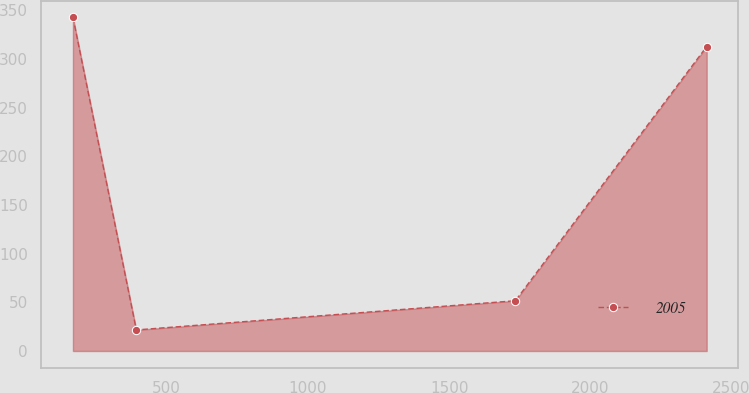<chart> <loc_0><loc_0><loc_500><loc_500><line_chart><ecel><fcel>2005<nl><fcel>167.89<fcel>342.9<nl><fcel>392.32<fcel>21.65<nl><fcel>1734.65<fcel>51.65<nl><fcel>2412.2<fcel>312.9<nl></chart> 